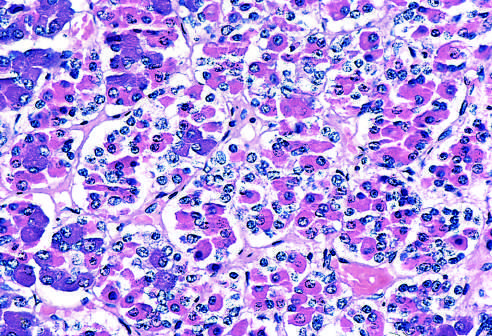what is populated by several distinct cell types that express different peptide hormones?
Answer the question using a single word or phrase. The normal anterior pituitary gland 